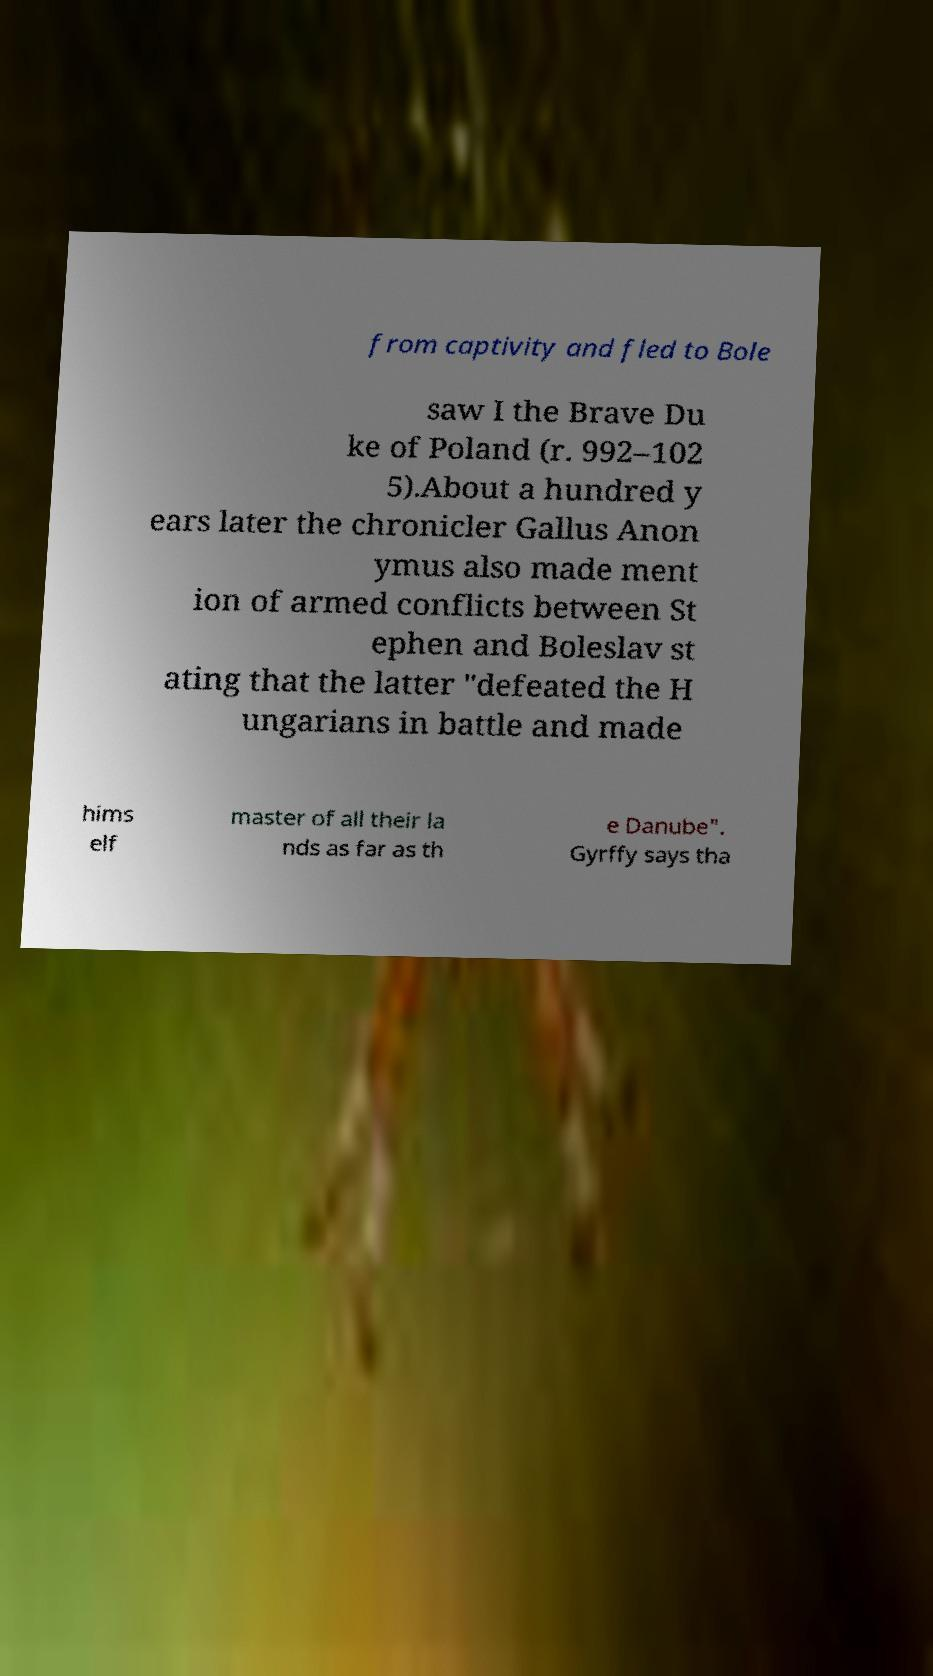I need the written content from this picture converted into text. Can you do that? from captivity and fled to Bole saw I the Brave Du ke of Poland (r. 992–102 5).About a hundred y ears later the chronicler Gallus Anon ymus also made ment ion of armed conflicts between St ephen and Boleslav st ating that the latter "defeated the H ungarians in battle and made hims elf master of all their la nds as far as th e Danube". Gyrffy says tha 